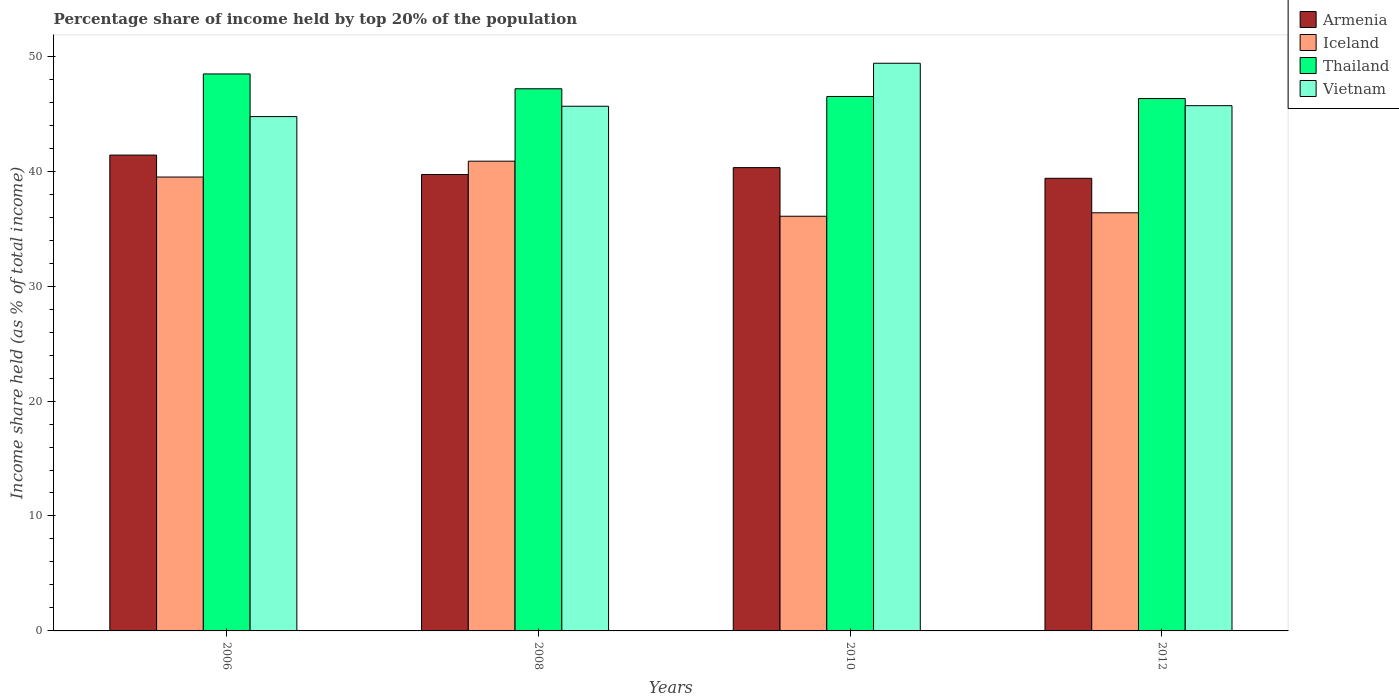Are the number of bars on each tick of the X-axis equal?
Give a very brief answer. Yes. How many bars are there on the 1st tick from the left?
Provide a succinct answer. 4. How many bars are there on the 1st tick from the right?
Keep it short and to the point. 4. What is the percentage share of income held by top 20% of the population in Vietnam in 2008?
Offer a terse response. 45.65. Across all years, what is the maximum percentage share of income held by top 20% of the population in Vietnam?
Make the answer very short. 49.39. Across all years, what is the minimum percentage share of income held by top 20% of the population in Thailand?
Your answer should be compact. 46.32. In which year was the percentage share of income held by top 20% of the population in Armenia minimum?
Offer a terse response. 2012. What is the total percentage share of income held by top 20% of the population in Thailand in the graph?
Offer a very short reply. 188.45. What is the difference between the percentage share of income held by top 20% of the population in Vietnam in 2006 and that in 2010?
Your response must be concise. -4.64. What is the difference between the percentage share of income held by top 20% of the population in Armenia in 2008 and the percentage share of income held by top 20% of the population in Thailand in 2010?
Provide a short and direct response. -6.79. What is the average percentage share of income held by top 20% of the population in Iceland per year?
Keep it short and to the point. 38.2. In the year 2010, what is the difference between the percentage share of income held by top 20% of the population in Thailand and percentage share of income held by top 20% of the population in Vietnam?
Your answer should be compact. -2.89. What is the ratio of the percentage share of income held by top 20% of the population in Iceland in 2006 to that in 2008?
Make the answer very short. 0.97. Is the difference between the percentage share of income held by top 20% of the population in Thailand in 2008 and 2012 greater than the difference between the percentage share of income held by top 20% of the population in Vietnam in 2008 and 2012?
Ensure brevity in your answer.  Yes. What is the difference between the highest and the second highest percentage share of income held by top 20% of the population in Iceland?
Provide a succinct answer. 1.38. What is the difference between the highest and the lowest percentage share of income held by top 20% of the population in Armenia?
Give a very brief answer. 2.02. Is the sum of the percentage share of income held by top 20% of the population in Thailand in 2006 and 2010 greater than the maximum percentage share of income held by top 20% of the population in Vietnam across all years?
Ensure brevity in your answer.  Yes. Are all the bars in the graph horizontal?
Give a very brief answer. No. How many years are there in the graph?
Keep it short and to the point. 4. What is the difference between two consecutive major ticks on the Y-axis?
Ensure brevity in your answer.  10. Does the graph contain grids?
Provide a succinct answer. No. How many legend labels are there?
Your answer should be very brief. 4. How are the legend labels stacked?
Give a very brief answer. Vertical. What is the title of the graph?
Give a very brief answer. Percentage share of income held by top 20% of the population. Does "Ethiopia" appear as one of the legend labels in the graph?
Provide a succinct answer. No. What is the label or title of the X-axis?
Ensure brevity in your answer.  Years. What is the label or title of the Y-axis?
Provide a short and direct response. Income share held (as % of total income). What is the Income share held (as % of total income) of Armenia in 2006?
Ensure brevity in your answer.  41.4. What is the Income share held (as % of total income) of Iceland in 2006?
Make the answer very short. 39.49. What is the Income share held (as % of total income) of Thailand in 2006?
Make the answer very short. 48.46. What is the Income share held (as % of total income) in Vietnam in 2006?
Your answer should be very brief. 44.75. What is the Income share held (as % of total income) in Armenia in 2008?
Provide a succinct answer. 39.71. What is the Income share held (as % of total income) of Iceland in 2008?
Ensure brevity in your answer.  40.87. What is the Income share held (as % of total income) of Thailand in 2008?
Offer a very short reply. 47.17. What is the Income share held (as % of total income) of Vietnam in 2008?
Give a very brief answer. 45.65. What is the Income share held (as % of total income) in Armenia in 2010?
Your answer should be compact. 40.31. What is the Income share held (as % of total income) in Iceland in 2010?
Your answer should be very brief. 36.08. What is the Income share held (as % of total income) of Thailand in 2010?
Offer a terse response. 46.5. What is the Income share held (as % of total income) of Vietnam in 2010?
Provide a succinct answer. 49.39. What is the Income share held (as % of total income) of Armenia in 2012?
Your answer should be very brief. 39.38. What is the Income share held (as % of total income) of Iceland in 2012?
Make the answer very short. 36.38. What is the Income share held (as % of total income) of Thailand in 2012?
Your response must be concise. 46.32. What is the Income share held (as % of total income) in Vietnam in 2012?
Make the answer very short. 45.7. Across all years, what is the maximum Income share held (as % of total income) in Armenia?
Give a very brief answer. 41.4. Across all years, what is the maximum Income share held (as % of total income) of Iceland?
Provide a succinct answer. 40.87. Across all years, what is the maximum Income share held (as % of total income) of Thailand?
Provide a succinct answer. 48.46. Across all years, what is the maximum Income share held (as % of total income) in Vietnam?
Keep it short and to the point. 49.39. Across all years, what is the minimum Income share held (as % of total income) of Armenia?
Make the answer very short. 39.38. Across all years, what is the minimum Income share held (as % of total income) in Iceland?
Give a very brief answer. 36.08. Across all years, what is the minimum Income share held (as % of total income) of Thailand?
Your answer should be very brief. 46.32. Across all years, what is the minimum Income share held (as % of total income) in Vietnam?
Make the answer very short. 44.75. What is the total Income share held (as % of total income) in Armenia in the graph?
Make the answer very short. 160.8. What is the total Income share held (as % of total income) in Iceland in the graph?
Your response must be concise. 152.82. What is the total Income share held (as % of total income) of Thailand in the graph?
Provide a succinct answer. 188.45. What is the total Income share held (as % of total income) in Vietnam in the graph?
Provide a short and direct response. 185.49. What is the difference between the Income share held (as % of total income) of Armenia in 2006 and that in 2008?
Offer a very short reply. 1.69. What is the difference between the Income share held (as % of total income) in Iceland in 2006 and that in 2008?
Keep it short and to the point. -1.38. What is the difference between the Income share held (as % of total income) of Thailand in 2006 and that in 2008?
Give a very brief answer. 1.29. What is the difference between the Income share held (as % of total income) in Vietnam in 2006 and that in 2008?
Offer a very short reply. -0.9. What is the difference between the Income share held (as % of total income) in Armenia in 2006 and that in 2010?
Offer a terse response. 1.09. What is the difference between the Income share held (as % of total income) in Iceland in 2006 and that in 2010?
Your answer should be compact. 3.41. What is the difference between the Income share held (as % of total income) of Thailand in 2006 and that in 2010?
Provide a short and direct response. 1.96. What is the difference between the Income share held (as % of total income) of Vietnam in 2006 and that in 2010?
Your answer should be very brief. -4.64. What is the difference between the Income share held (as % of total income) of Armenia in 2006 and that in 2012?
Give a very brief answer. 2.02. What is the difference between the Income share held (as % of total income) in Iceland in 2006 and that in 2012?
Give a very brief answer. 3.11. What is the difference between the Income share held (as % of total income) of Thailand in 2006 and that in 2012?
Keep it short and to the point. 2.14. What is the difference between the Income share held (as % of total income) of Vietnam in 2006 and that in 2012?
Give a very brief answer. -0.95. What is the difference between the Income share held (as % of total income) of Iceland in 2008 and that in 2010?
Make the answer very short. 4.79. What is the difference between the Income share held (as % of total income) of Thailand in 2008 and that in 2010?
Provide a succinct answer. 0.67. What is the difference between the Income share held (as % of total income) of Vietnam in 2008 and that in 2010?
Your response must be concise. -3.74. What is the difference between the Income share held (as % of total income) of Armenia in 2008 and that in 2012?
Make the answer very short. 0.33. What is the difference between the Income share held (as % of total income) in Iceland in 2008 and that in 2012?
Provide a short and direct response. 4.49. What is the difference between the Income share held (as % of total income) of Vietnam in 2008 and that in 2012?
Keep it short and to the point. -0.05. What is the difference between the Income share held (as % of total income) in Iceland in 2010 and that in 2012?
Your answer should be compact. -0.3. What is the difference between the Income share held (as % of total income) of Thailand in 2010 and that in 2012?
Offer a very short reply. 0.18. What is the difference between the Income share held (as % of total income) of Vietnam in 2010 and that in 2012?
Ensure brevity in your answer.  3.69. What is the difference between the Income share held (as % of total income) of Armenia in 2006 and the Income share held (as % of total income) of Iceland in 2008?
Provide a succinct answer. 0.53. What is the difference between the Income share held (as % of total income) of Armenia in 2006 and the Income share held (as % of total income) of Thailand in 2008?
Your answer should be compact. -5.77. What is the difference between the Income share held (as % of total income) of Armenia in 2006 and the Income share held (as % of total income) of Vietnam in 2008?
Offer a very short reply. -4.25. What is the difference between the Income share held (as % of total income) in Iceland in 2006 and the Income share held (as % of total income) in Thailand in 2008?
Keep it short and to the point. -7.68. What is the difference between the Income share held (as % of total income) in Iceland in 2006 and the Income share held (as % of total income) in Vietnam in 2008?
Offer a terse response. -6.16. What is the difference between the Income share held (as % of total income) in Thailand in 2006 and the Income share held (as % of total income) in Vietnam in 2008?
Offer a terse response. 2.81. What is the difference between the Income share held (as % of total income) of Armenia in 2006 and the Income share held (as % of total income) of Iceland in 2010?
Provide a short and direct response. 5.32. What is the difference between the Income share held (as % of total income) in Armenia in 2006 and the Income share held (as % of total income) in Vietnam in 2010?
Offer a terse response. -7.99. What is the difference between the Income share held (as % of total income) in Iceland in 2006 and the Income share held (as % of total income) in Thailand in 2010?
Your answer should be compact. -7.01. What is the difference between the Income share held (as % of total income) in Thailand in 2006 and the Income share held (as % of total income) in Vietnam in 2010?
Offer a very short reply. -0.93. What is the difference between the Income share held (as % of total income) in Armenia in 2006 and the Income share held (as % of total income) in Iceland in 2012?
Offer a very short reply. 5.02. What is the difference between the Income share held (as % of total income) in Armenia in 2006 and the Income share held (as % of total income) in Thailand in 2012?
Your response must be concise. -4.92. What is the difference between the Income share held (as % of total income) of Armenia in 2006 and the Income share held (as % of total income) of Vietnam in 2012?
Provide a succinct answer. -4.3. What is the difference between the Income share held (as % of total income) of Iceland in 2006 and the Income share held (as % of total income) of Thailand in 2012?
Provide a succinct answer. -6.83. What is the difference between the Income share held (as % of total income) in Iceland in 2006 and the Income share held (as % of total income) in Vietnam in 2012?
Offer a very short reply. -6.21. What is the difference between the Income share held (as % of total income) in Thailand in 2006 and the Income share held (as % of total income) in Vietnam in 2012?
Provide a succinct answer. 2.76. What is the difference between the Income share held (as % of total income) in Armenia in 2008 and the Income share held (as % of total income) in Iceland in 2010?
Provide a succinct answer. 3.63. What is the difference between the Income share held (as % of total income) of Armenia in 2008 and the Income share held (as % of total income) of Thailand in 2010?
Keep it short and to the point. -6.79. What is the difference between the Income share held (as % of total income) of Armenia in 2008 and the Income share held (as % of total income) of Vietnam in 2010?
Ensure brevity in your answer.  -9.68. What is the difference between the Income share held (as % of total income) in Iceland in 2008 and the Income share held (as % of total income) in Thailand in 2010?
Your answer should be compact. -5.63. What is the difference between the Income share held (as % of total income) of Iceland in 2008 and the Income share held (as % of total income) of Vietnam in 2010?
Keep it short and to the point. -8.52. What is the difference between the Income share held (as % of total income) of Thailand in 2008 and the Income share held (as % of total income) of Vietnam in 2010?
Your answer should be compact. -2.22. What is the difference between the Income share held (as % of total income) in Armenia in 2008 and the Income share held (as % of total income) in Iceland in 2012?
Provide a succinct answer. 3.33. What is the difference between the Income share held (as % of total income) of Armenia in 2008 and the Income share held (as % of total income) of Thailand in 2012?
Your answer should be very brief. -6.61. What is the difference between the Income share held (as % of total income) in Armenia in 2008 and the Income share held (as % of total income) in Vietnam in 2012?
Offer a very short reply. -5.99. What is the difference between the Income share held (as % of total income) in Iceland in 2008 and the Income share held (as % of total income) in Thailand in 2012?
Give a very brief answer. -5.45. What is the difference between the Income share held (as % of total income) in Iceland in 2008 and the Income share held (as % of total income) in Vietnam in 2012?
Your response must be concise. -4.83. What is the difference between the Income share held (as % of total income) of Thailand in 2008 and the Income share held (as % of total income) of Vietnam in 2012?
Give a very brief answer. 1.47. What is the difference between the Income share held (as % of total income) of Armenia in 2010 and the Income share held (as % of total income) of Iceland in 2012?
Your answer should be compact. 3.93. What is the difference between the Income share held (as % of total income) in Armenia in 2010 and the Income share held (as % of total income) in Thailand in 2012?
Offer a very short reply. -6.01. What is the difference between the Income share held (as % of total income) in Armenia in 2010 and the Income share held (as % of total income) in Vietnam in 2012?
Your answer should be very brief. -5.39. What is the difference between the Income share held (as % of total income) in Iceland in 2010 and the Income share held (as % of total income) in Thailand in 2012?
Your answer should be very brief. -10.24. What is the difference between the Income share held (as % of total income) of Iceland in 2010 and the Income share held (as % of total income) of Vietnam in 2012?
Provide a short and direct response. -9.62. What is the difference between the Income share held (as % of total income) in Thailand in 2010 and the Income share held (as % of total income) in Vietnam in 2012?
Your answer should be very brief. 0.8. What is the average Income share held (as % of total income) of Armenia per year?
Your answer should be very brief. 40.2. What is the average Income share held (as % of total income) of Iceland per year?
Make the answer very short. 38.2. What is the average Income share held (as % of total income) of Thailand per year?
Offer a very short reply. 47.11. What is the average Income share held (as % of total income) in Vietnam per year?
Offer a terse response. 46.37. In the year 2006, what is the difference between the Income share held (as % of total income) in Armenia and Income share held (as % of total income) in Iceland?
Make the answer very short. 1.91. In the year 2006, what is the difference between the Income share held (as % of total income) of Armenia and Income share held (as % of total income) of Thailand?
Give a very brief answer. -7.06. In the year 2006, what is the difference between the Income share held (as % of total income) in Armenia and Income share held (as % of total income) in Vietnam?
Provide a short and direct response. -3.35. In the year 2006, what is the difference between the Income share held (as % of total income) in Iceland and Income share held (as % of total income) in Thailand?
Ensure brevity in your answer.  -8.97. In the year 2006, what is the difference between the Income share held (as % of total income) in Iceland and Income share held (as % of total income) in Vietnam?
Ensure brevity in your answer.  -5.26. In the year 2006, what is the difference between the Income share held (as % of total income) in Thailand and Income share held (as % of total income) in Vietnam?
Give a very brief answer. 3.71. In the year 2008, what is the difference between the Income share held (as % of total income) of Armenia and Income share held (as % of total income) of Iceland?
Provide a short and direct response. -1.16. In the year 2008, what is the difference between the Income share held (as % of total income) of Armenia and Income share held (as % of total income) of Thailand?
Keep it short and to the point. -7.46. In the year 2008, what is the difference between the Income share held (as % of total income) of Armenia and Income share held (as % of total income) of Vietnam?
Your answer should be very brief. -5.94. In the year 2008, what is the difference between the Income share held (as % of total income) in Iceland and Income share held (as % of total income) in Thailand?
Provide a short and direct response. -6.3. In the year 2008, what is the difference between the Income share held (as % of total income) of Iceland and Income share held (as % of total income) of Vietnam?
Give a very brief answer. -4.78. In the year 2008, what is the difference between the Income share held (as % of total income) of Thailand and Income share held (as % of total income) of Vietnam?
Ensure brevity in your answer.  1.52. In the year 2010, what is the difference between the Income share held (as % of total income) in Armenia and Income share held (as % of total income) in Iceland?
Give a very brief answer. 4.23. In the year 2010, what is the difference between the Income share held (as % of total income) of Armenia and Income share held (as % of total income) of Thailand?
Give a very brief answer. -6.19. In the year 2010, what is the difference between the Income share held (as % of total income) in Armenia and Income share held (as % of total income) in Vietnam?
Ensure brevity in your answer.  -9.08. In the year 2010, what is the difference between the Income share held (as % of total income) of Iceland and Income share held (as % of total income) of Thailand?
Make the answer very short. -10.42. In the year 2010, what is the difference between the Income share held (as % of total income) of Iceland and Income share held (as % of total income) of Vietnam?
Provide a short and direct response. -13.31. In the year 2010, what is the difference between the Income share held (as % of total income) of Thailand and Income share held (as % of total income) of Vietnam?
Keep it short and to the point. -2.89. In the year 2012, what is the difference between the Income share held (as % of total income) of Armenia and Income share held (as % of total income) of Thailand?
Provide a short and direct response. -6.94. In the year 2012, what is the difference between the Income share held (as % of total income) in Armenia and Income share held (as % of total income) in Vietnam?
Make the answer very short. -6.32. In the year 2012, what is the difference between the Income share held (as % of total income) in Iceland and Income share held (as % of total income) in Thailand?
Offer a very short reply. -9.94. In the year 2012, what is the difference between the Income share held (as % of total income) in Iceland and Income share held (as % of total income) in Vietnam?
Your response must be concise. -9.32. In the year 2012, what is the difference between the Income share held (as % of total income) in Thailand and Income share held (as % of total income) in Vietnam?
Offer a terse response. 0.62. What is the ratio of the Income share held (as % of total income) of Armenia in 2006 to that in 2008?
Offer a very short reply. 1.04. What is the ratio of the Income share held (as % of total income) in Iceland in 2006 to that in 2008?
Offer a very short reply. 0.97. What is the ratio of the Income share held (as % of total income) in Thailand in 2006 to that in 2008?
Your response must be concise. 1.03. What is the ratio of the Income share held (as % of total income) of Vietnam in 2006 to that in 2008?
Keep it short and to the point. 0.98. What is the ratio of the Income share held (as % of total income) in Iceland in 2006 to that in 2010?
Offer a very short reply. 1.09. What is the ratio of the Income share held (as % of total income) of Thailand in 2006 to that in 2010?
Give a very brief answer. 1.04. What is the ratio of the Income share held (as % of total income) in Vietnam in 2006 to that in 2010?
Keep it short and to the point. 0.91. What is the ratio of the Income share held (as % of total income) of Armenia in 2006 to that in 2012?
Offer a very short reply. 1.05. What is the ratio of the Income share held (as % of total income) of Iceland in 2006 to that in 2012?
Keep it short and to the point. 1.09. What is the ratio of the Income share held (as % of total income) of Thailand in 2006 to that in 2012?
Provide a short and direct response. 1.05. What is the ratio of the Income share held (as % of total income) of Vietnam in 2006 to that in 2012?
Keep it short and to the point. 0.98. What is the ratio of the Income share held (as % of total income) in Armenia in 2008 to that in 2010?
Provide a short and direct response. 0.99. What is the ratio of the Income share held (as % of total income) in Iceland in 2008 to that in 2010?
Your answer should be very brief. 1.13. What is the ratio of the Income share held (as % of total income) in Thailand in 2008 to that in 2010?
Ensure brevity in your answer.  1.01. What is the ratio of the Income share held (as % of total income) in Vietnam in 2008 to that in 2010?
Make the answer very short. 0.92. What is the ratio of the Income share held (as % of total income) of Armenia in 2008 to that in 2012?
Your answer should be very brief. 1.01. What is the ratio of the Income share held (as % of total income) of Iceland in 2008 to that in 2012?
Provide a succinct answer. 1.12. What is the ratio of the Income share held (as % of total income) of Thailand in 2008 to that in 2012?
Provide a succinct answer. 1.02. What is the ratio of the Income share held (as % of total income) in Armenia in 2010 to that in 2012?
Offer a terse response. 1.02. What is the ratio of the Income share held (as % of total income) of Iceland in 2010 to that in 2012?
Offer a terse response. 0.99. What is the ratio of the Income share held (as % of total income) in Thailand in 2010 to that in 2012?
Your response must be concise. 1. What is the ratio of the Income share held (as % of total income) of Vietnam in 2010 to that in 2012?
Offer a very short reply. 1.08. What is the difference between the highest and the second highest Income share held (as % of total income) of Armenia?
Provide a succinct answer. 1.09. What is the difference between the highest and the second highest Income share held (as % of total income) of Iceland?
Make the answer very short. 1.38. What is the difference between the highest and the second highest Income share held (as % of total income) of Thailand?
Make the answer very short. 1.29. What is the difference between the highest and the second highest Income share held (as % of total income) in Vietnam?
Offer a very short reply. 3.69. What is the difference between the highest and the lowest Income share held (as % of total income) of Armenia?
Make the answer very short. 2.02. What is the difference between the highest and the lowest Income share held (as % of total income) of Iceland?
Offer a terse response. 4.79. What is the difference between the highest and the lowest Income share held (as % of total income) in Thailand?
Give a very brief answer. 2.14. What is the difference between the highest and the lowest Income share held (as % of total income) in Vietnam?
Offer a terse response. 4.64. 